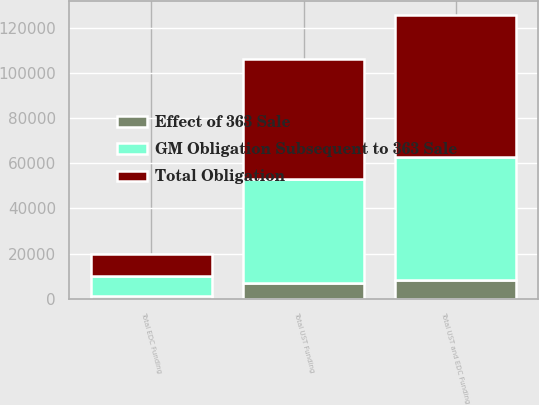<chart> <loc_0><loc_0><loc_500><loc_500><stacked_bar_chart><ecel><fcel>Total UST Funding<fcel>Total EDC Funding<fcel>Total UST and EDC Funding<nl><fcel>Total Obligation<fcel>53041<fcel>9868<fcel>62909<nl><fcel>GM Obligation Subsequent to 363 Sale<fcel>45968<fcel>8576<fcel>54544<nl><fcel>Effect of 363 Sale<fcel>7073<fcel>1292<fcel>8365<nl></chart> 